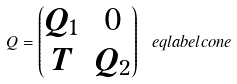<formula> <loc_0><loc_0><loc_500><loc_500>Q = \begin{pmatrix} Q _ { 1 } & 0 \\ T & Q _ { 2 } \end{pmatrix} \ e q l a b e l { c o n e }</formula> 